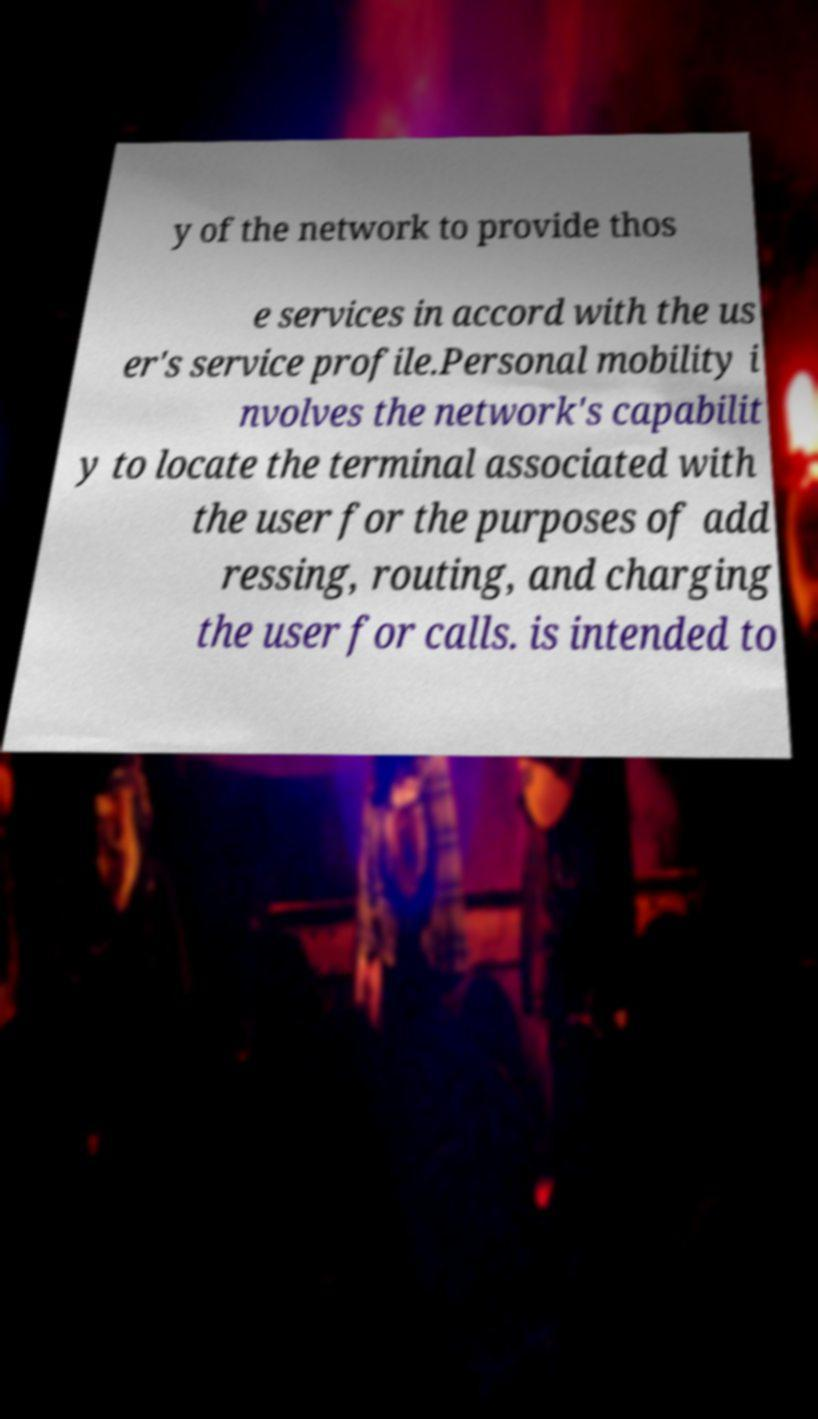Can you read and provide the text displayed in the image?This photo seems to have some interesting text. Can you extract and type it out for me? y of the network to provide thos e services in accord with the us er's service profile.Personal mobility i nvolves the network's capabilit y to locate the terminal associated with the user for the purposes of add ressing, routing, and charging the user for calls. is intended to 